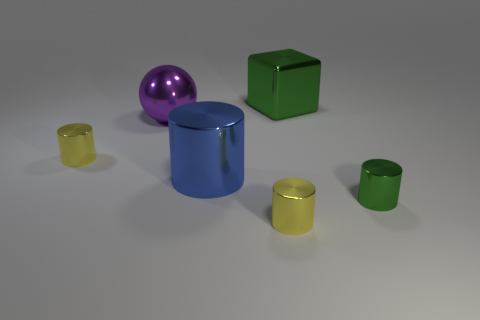Subtract all brown cylinders. Subtract all green blocks. How many cylinders are left? 4 Add 2 gray cylinders. How many objects exist? 8 Subtract all balls. How many objects are left? 5 Add 6 yellow cylinders. How many yellow cylinders exist? 8 Subtract 0 yellow spheres. How many objects are left? 6 Subtract all small green cylinders. Subtract all small green objects. How many objects are left? 4 Add 1 purple metal spheres. How many purple metal spheres are left? 2 